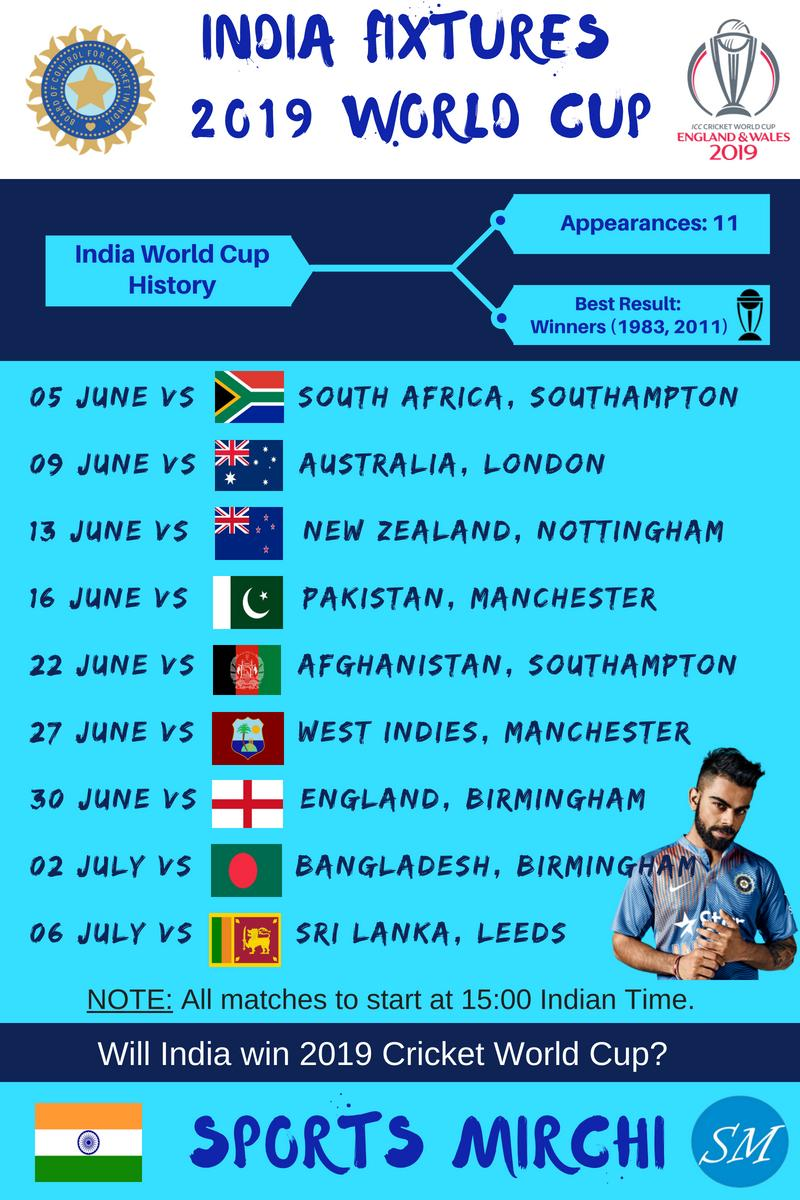Draw attention to some important aspects in this diagram. India has won the Cricket World Cup two times. India won their last Cricket World Cup in 2011. India won their first cricket World Cup in 1983. 